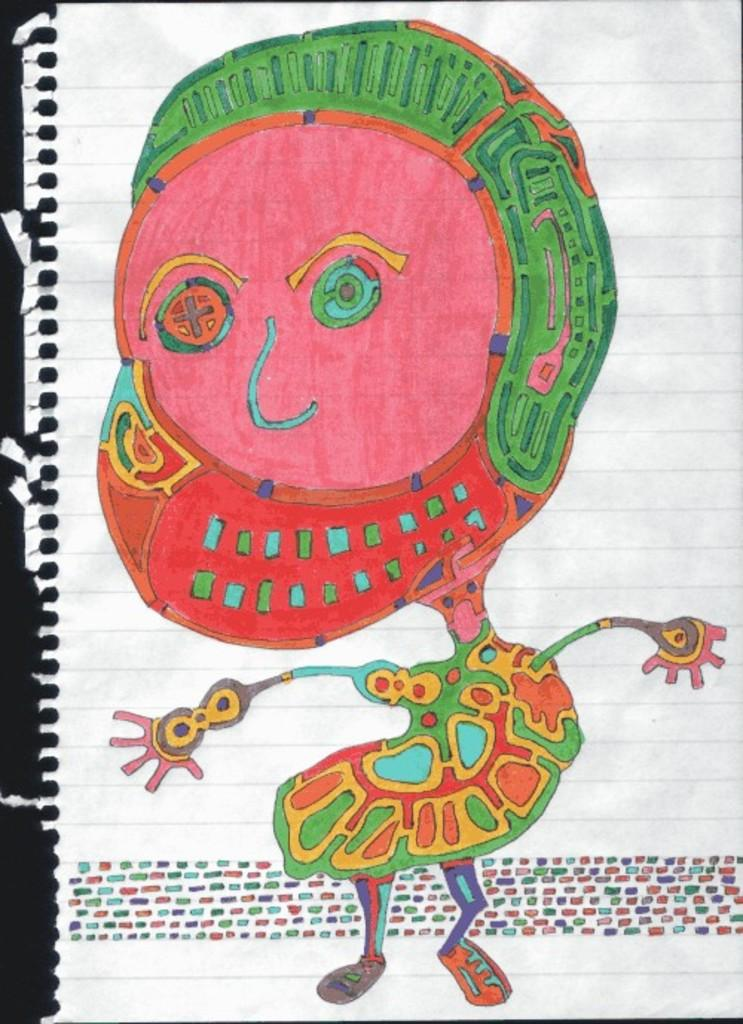What is present on the paper in the image? There is a picture drawn on the paper. Can you describe the picture on the paper? The picture is filled with colors. What type of air can be seen coming out of the can in the image? There is no can or air present in the image; it only features a paper with a colored picture drawn on it. What type of slip can be seen on the floor in the image? There is no slip present in the image. 